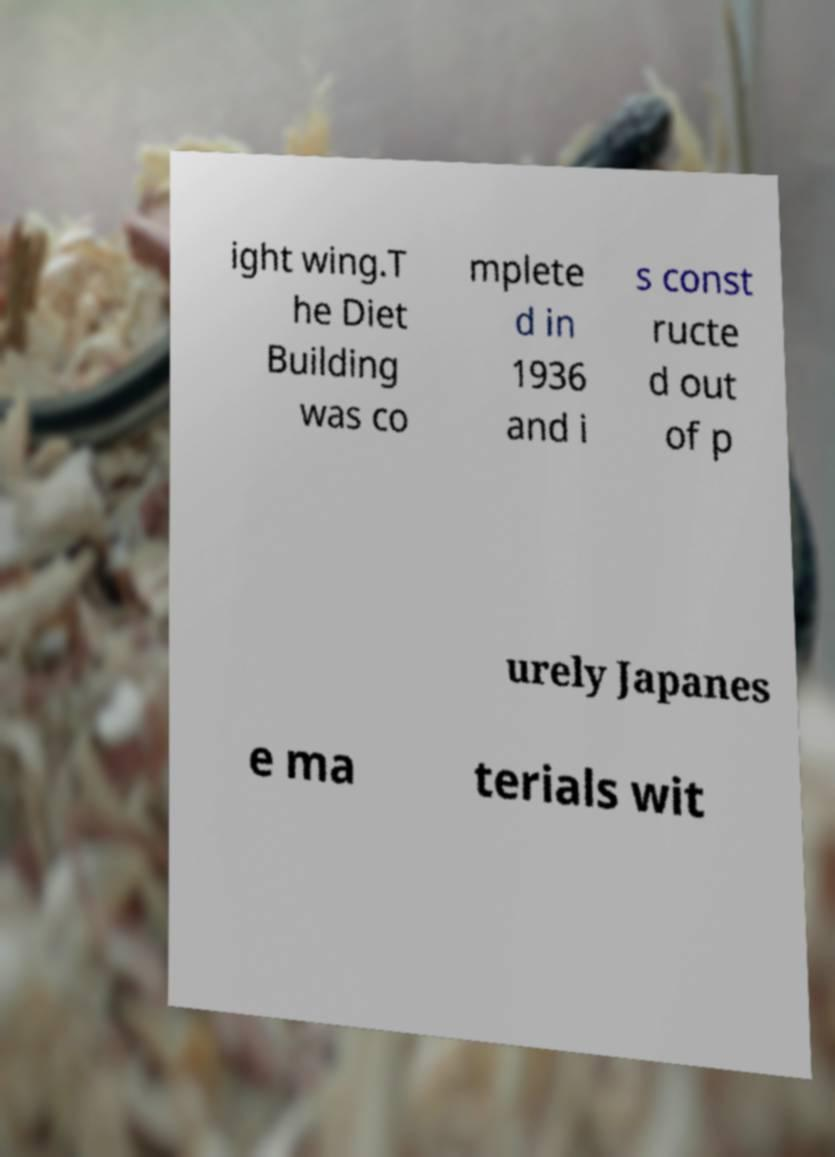Please identify and transcribe the text found in this image. ight wing.T he Diet Building was co mplete d in 1936 and i s const ructe d out of p urely Japanes e ma terials wit 